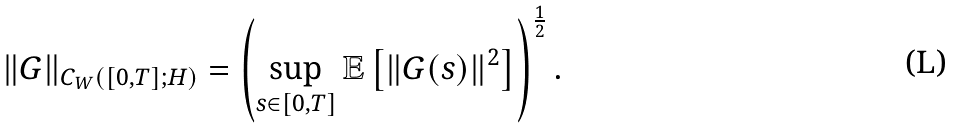Convert formula to latex. <formula><loc_0><loc_0><loc_500><loc_500>\| G \| _ { C _ { W } ( [ 0 , T ] ; H ) } = \left ( \sup _ { s \in [ 0 , T ] } \mathbb { E } \left [ \| G ( s ) \| ^ { 2 } \right ] \right ) ^ { \frac { 1 } { 2 } } .</formula> 